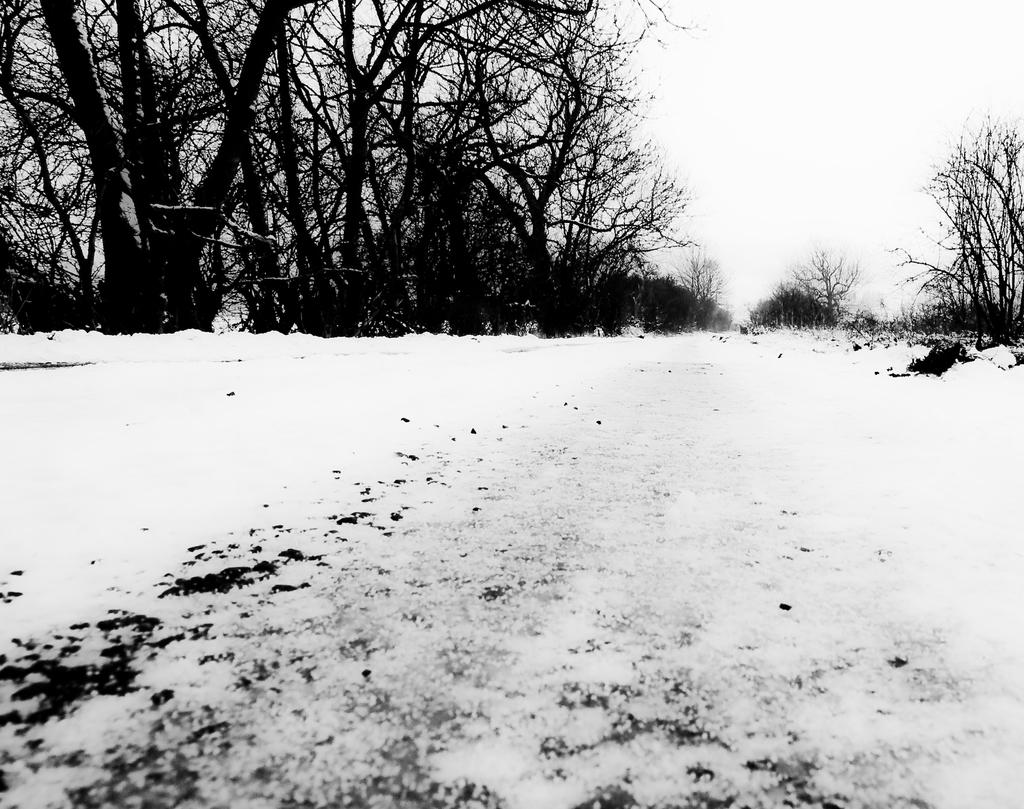What type of vegetation can be seen in the image? There are trees in the image. What is covering the ground in the image? There is snow on the ground in the image. What is the condition of the sky in the image? The sky is cloudy in the image. Can you see a bit of cherry on the trees in the image? There is no mention of cherries or any fruit in the image; it features trees with snow on the ground and a cloudy sky. 